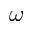Convert formula to latex. <formula><loc_0><loc_0><loc_500><loc_500>\omega</formula> 